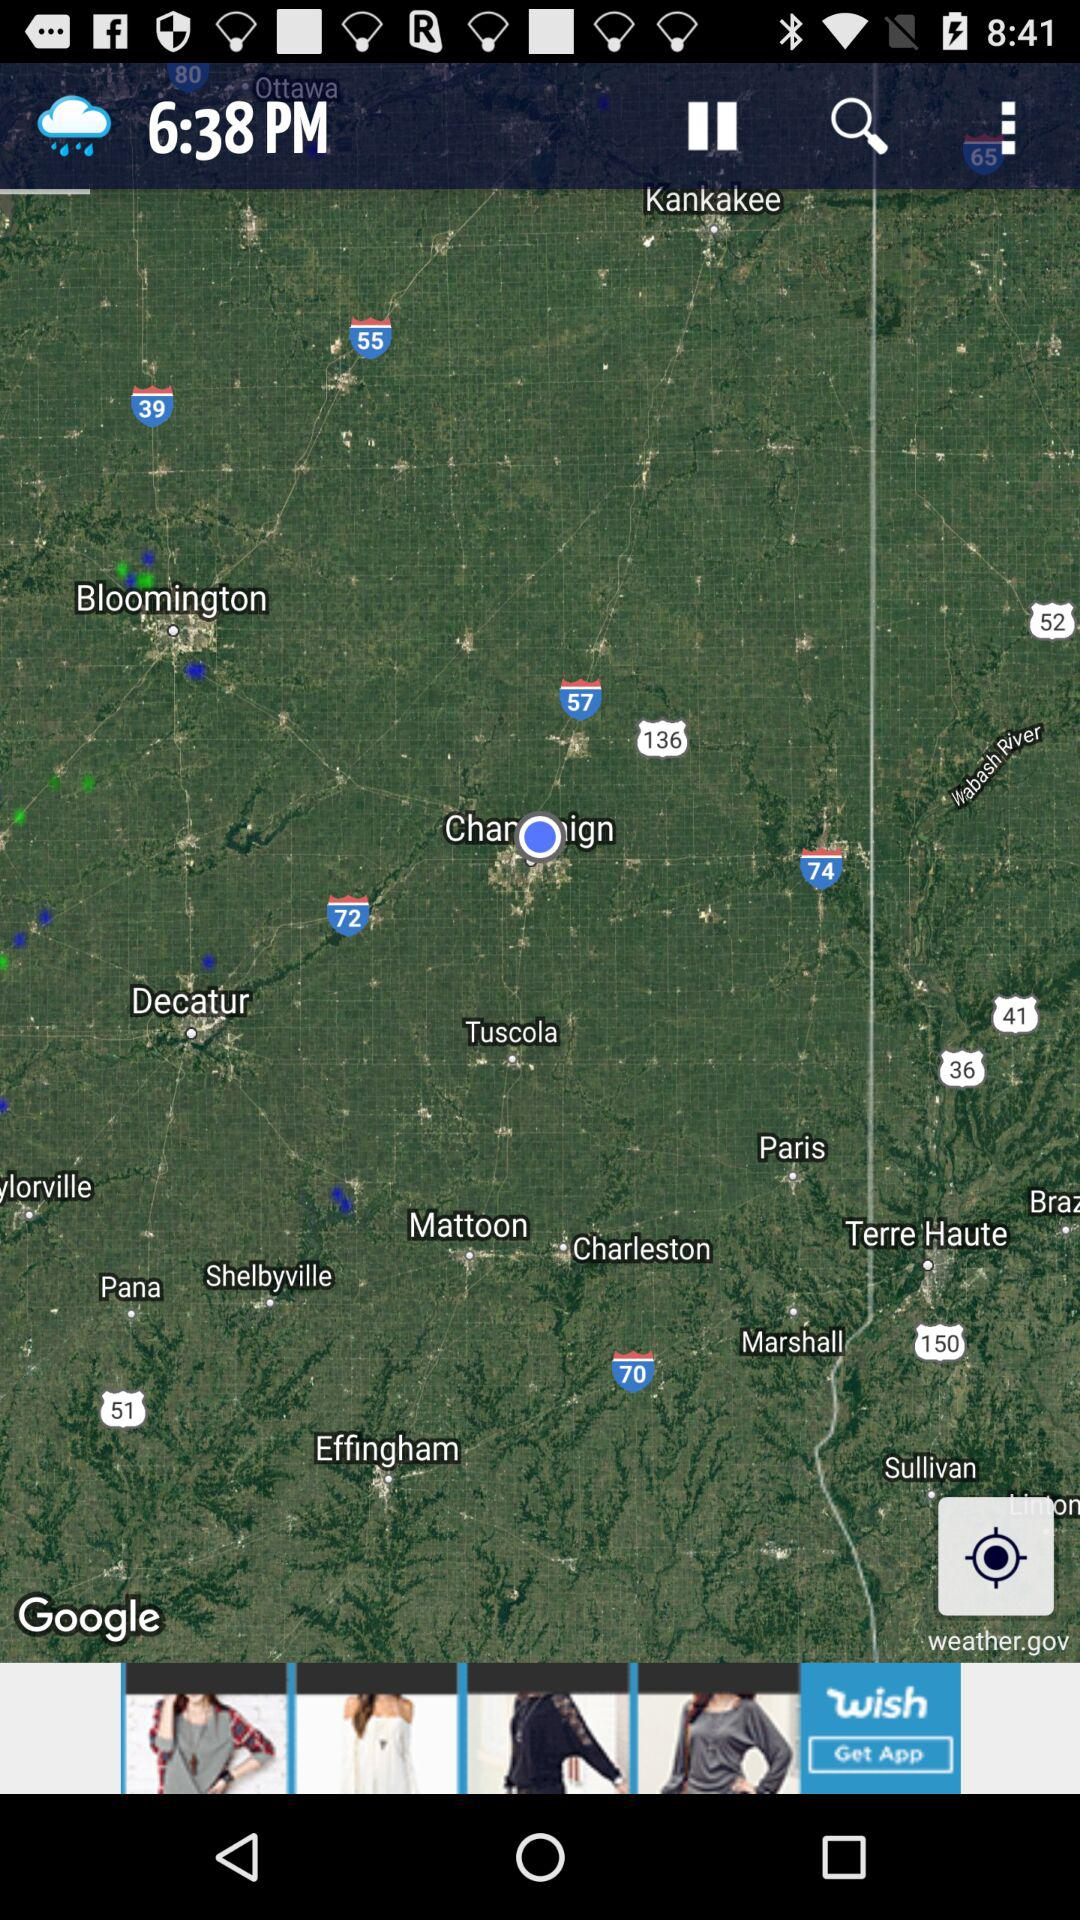What is the time mentioned? The time is 6:38 PM. 